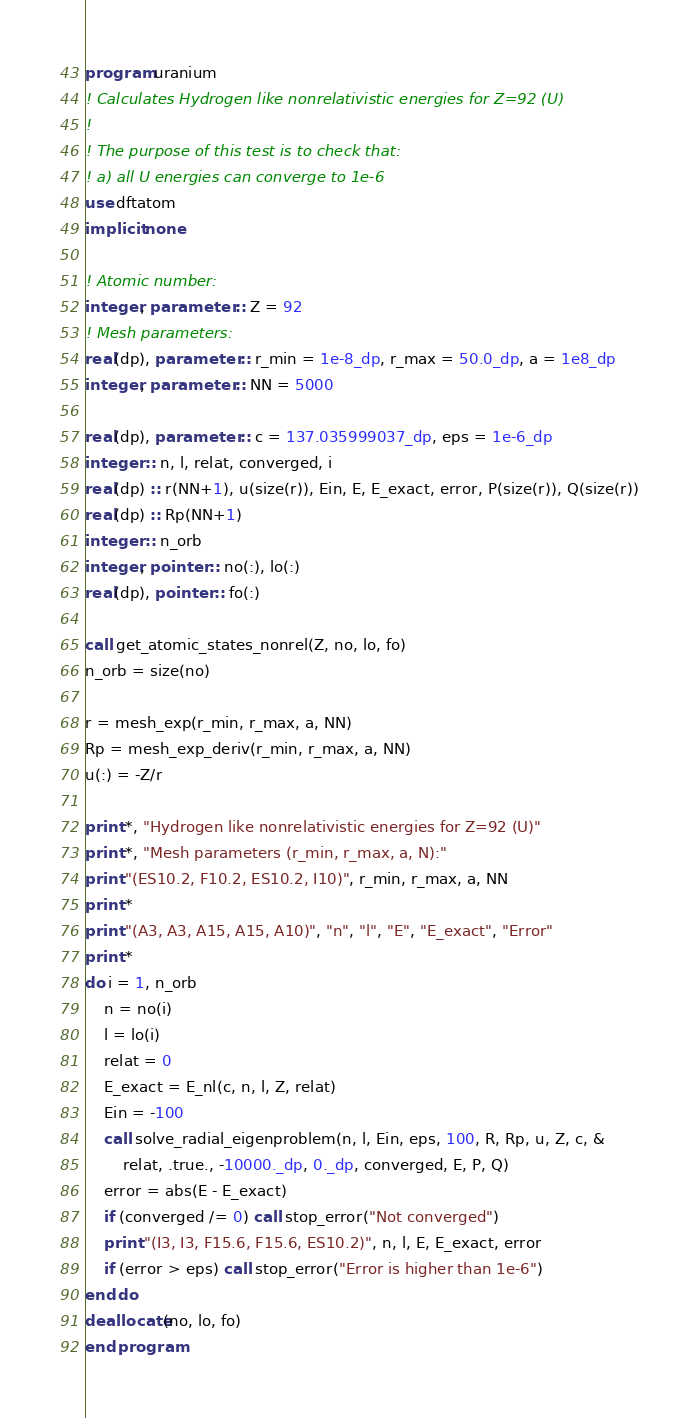Convert code to text. <code><loc_0><loc_0><loc_500><loc_500><_FORTRAN_>program uranium
! Calculates Hydrogen like nonrelativistic energies for Z=92 (U)
!
! The purpose of this test is to check that:
! a) all U energies can converge to 1e-6
use dftatom
implicit none

! Atomic number:
integer, parameter :: Z = 92
! Mesh parameters:
real(dp), parameter :: r_min = 1e-8_dp, r_max = 50.0_dp, a = 1e8_dp
integer, parameter :: NN = 5000

real(dp), parameter :: c = 137.035999037_dp, eps = 1e-6_dp
integer :: n, l, relat, converged, i
real(dp) :: r(NN+1), u(size(r)), Ein, E, E_exact, error, P(size(r)), Q(size(r))
real(dp) :: Rp(NN+1)
integer :: n_orb
integer, pointer :: no(:), lo(:)
real(dp), pointer :: fo(:)

call get_atomic_states_nonrel(Z, no, lo, fo)
n_orb = size(no)

r = mesh_exp(r_min, r_max, a, NN)
Rp = mesh_exp_deriv(r_min, r_max, a, NN)
u(:) = -Z/r

print *, "Hydrogen like nonrelativistic energies for Z=92 (U)"
print *, "Mesh parameters (r_min, r_max, a, N):"
print "(ES10.2, F10.2, ES10.2, I10)", r_min, r_max, a, NN
print *
print "(A3, A3, A15, A15, A10)", "n", "l", "E", "E_exact", "Error"
print *
do i = 1, n_orb
    n = no(i)
    l = lo(i)
    relat = 0
    E_exact = E_nl(c, n, l, Z, relat)
    Ein = -100
    call solve_radial_eigenproblem(n, l, Ein, eps, 100, R, Rp, u, Z, c, &
        relat, .true., -10000._dp, 0._dp, converged, E, P, Q)
    error = abs(E - E_exact)
    if (converged /= 0) call stop_error("Not converged")
    print "(I3, I3, F15.6, F15.6, ES10.2)", n, l, E, E_exact, error
    if (error > eps) call stop_error("Error is higher than 1e-6")
end do
deallocate(no, lo, fo)
end program
</code> 